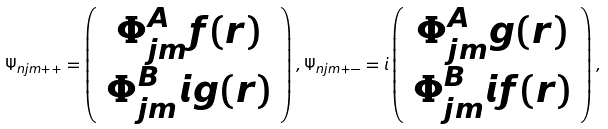<formula> <loc_0><loc_0><loc_500><loc_500>\Psi _ { n j m + + } = \left ( \begin{array} { c } \Phi _ { j m } ^ { A } f ( r ) \\ \Phi _ { j m } ^ { B } i g ( r ) \end{array} \right ) , \Psi _ { n j m + - } = i \left ( \begin{array} { c } \Phi _ { j m } ^ { A } g ( r ) \\ \Phi _ { j m } ^ { B } i f ( r ) \end{array} \right ) ,</formula> 